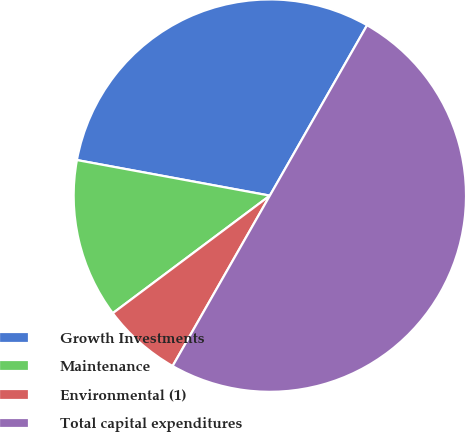Convert chart. <chart><loc_0><loc_0><loc_500><loc_500><pie_chart><fcel>Growth Investments<fcel>Maintenance<fcel>Environmental (1)<fcel>Total capital expenditures<nl><fcel>30.35%<fcel>13.13%<fcel>6.52%<fcel>50.0%<nl></chart> 